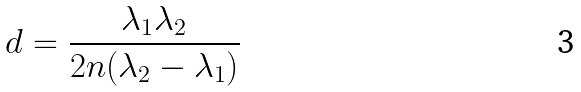Convert formula to latex. <formula><loc_0><loc_0><loc_500><loc_500>d = \frac { \lambda _ { 1 } \lambda _ { 2 } } { 2 n ( \lambda _ { 2 } - \lambda _ { 1 } ) }</formula> 